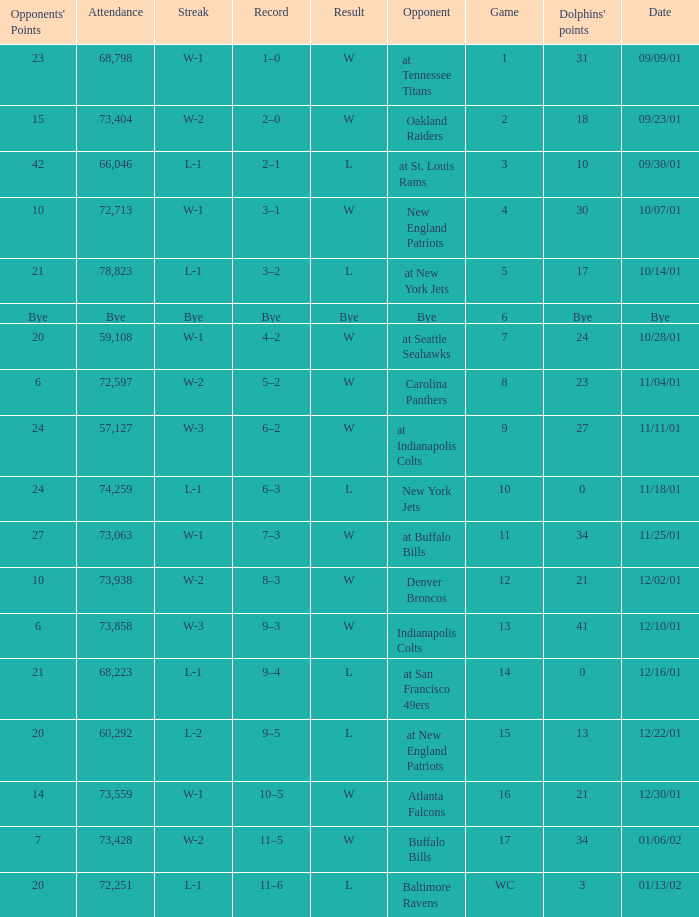Which opponent had 73,428 in attendance? Buffalo Bills. 